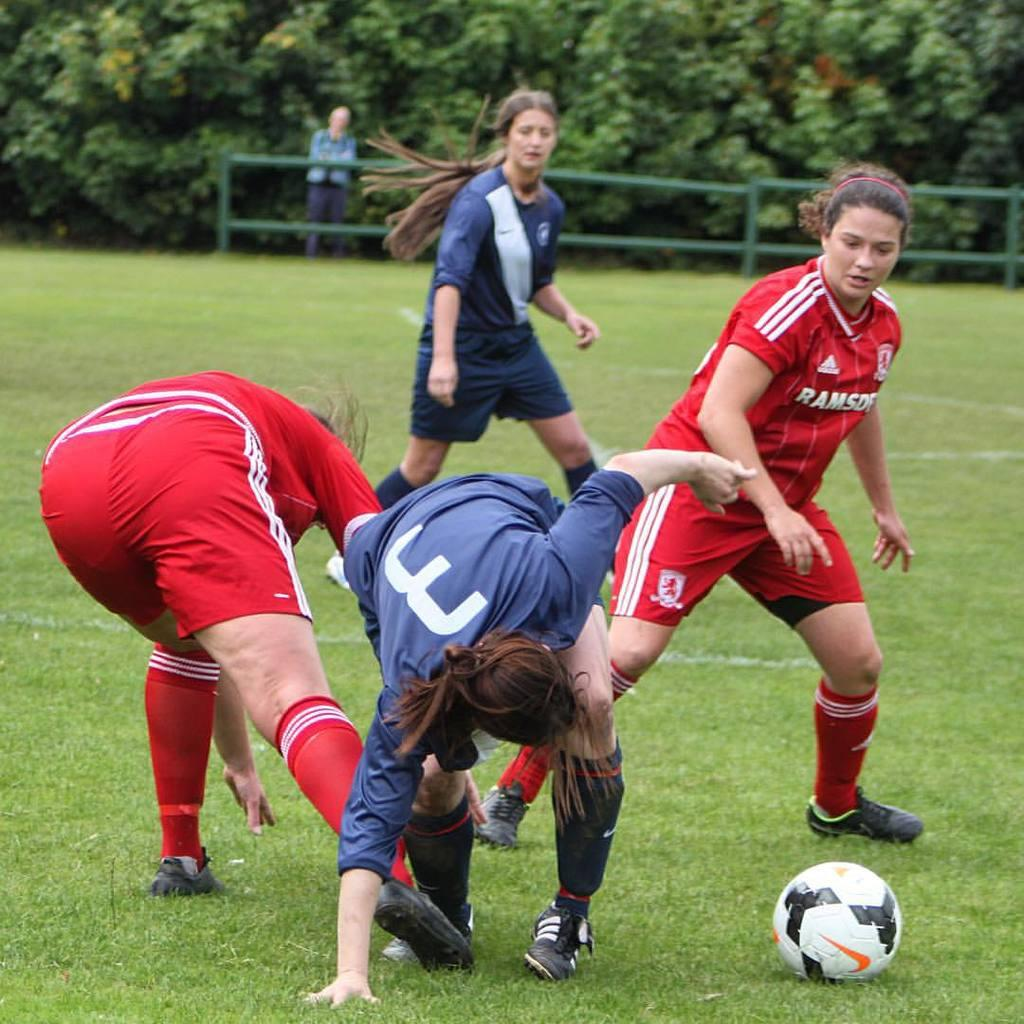<image>
Provide a brief description of the given image. Player number 3 in blue fighting for the ball in a soccer game. 